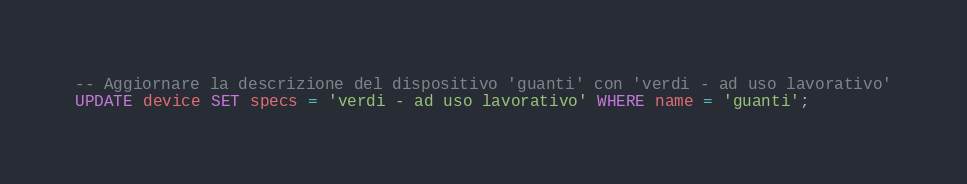Convert code to text. <code><loc_0><loc_0><loc_500><loc_500><_SQL_>-- Aggiornare la descrizione del dispositivo 'guanti' con 'verdi - ad uso lavorativo'
UPDATE device SET specs = 'verdi - ad uso lavorativo' WHERE name = 'guanti';
</code> 